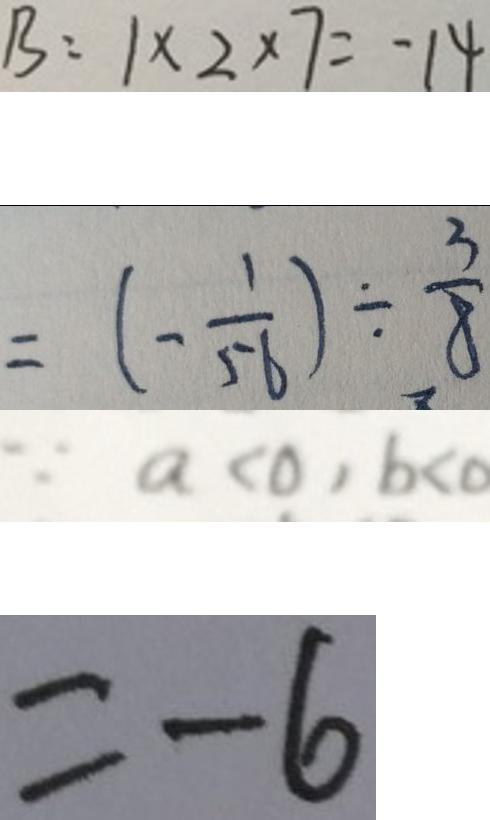<formula> <loc_0><loc_0><loc_500><loc_500>B : 1 \times 2 \times 7 = - 1 4 
 = ( - \frac { 1 } { 5 6 } ) \div \frac { 3 } { 8 } 
 \because a < 0 , b < 0 
 = - 6</formula> 